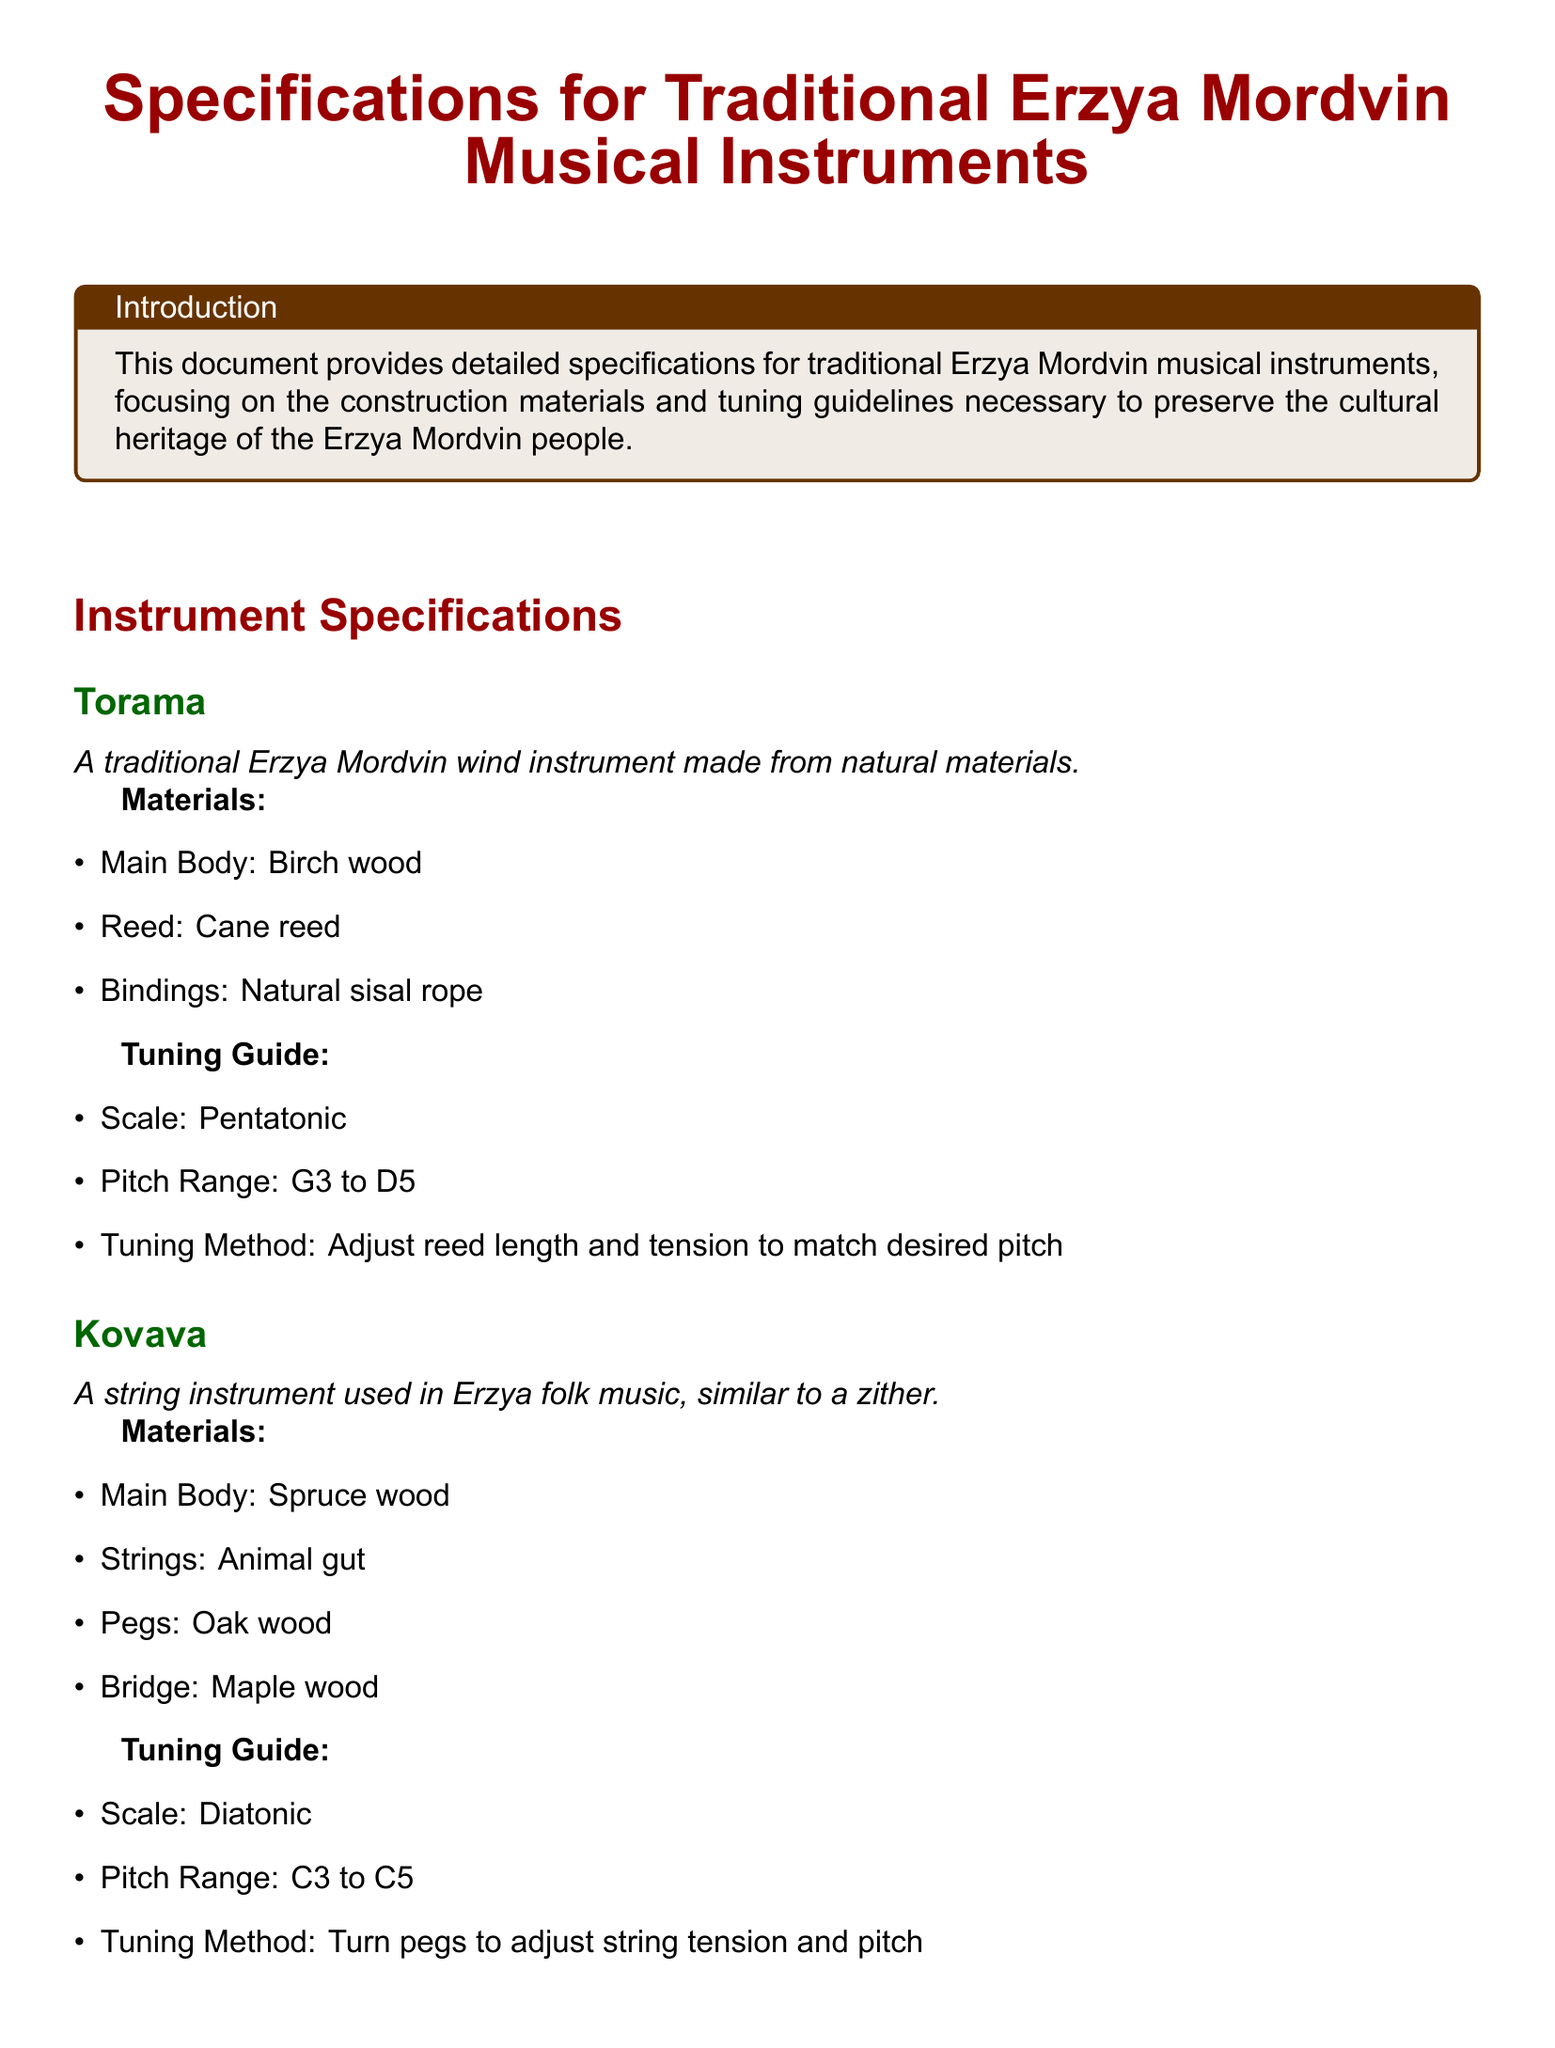What is the main body material of Torama? The main body of the Torama is made from birch wood.
Answer: Birch wood What is the pitch range of the Kovava? The pitch range of the Kovava is specified as C3 to C5.
Answer: C3 to C5 What type of instrument is Shuvyr? The Shuvyr is described as a percussion instrument.
Answer: Percussion instrument What materials are used for the bindings of Torama? The bindings of the Torama are made from natural sisal rope.
Answer: Natural sisal rope What tuning method is used for the Shuvyr? The tuning method for the Shuvyr involves tightening or loosening leather straps.
Answer: Tighten or loosen leather straps What scale does the Torama utilize? The Torama utilizes a pentatonic scale for tuning.
Answer: Pentatonic How is the tuning adjusted for the Kovava? The tuning for the Kovava is adjusted by turning pegs to change string tension and pitch.
Answer: Turn pegs to adjust string tension What type of skin is used for the membrane of Shuvyr? The membrane of the Shuvyr is made from animal skin.
Answer: Animal skin What is the main body material of Kovava? The main body of the Kovava is made from spruce wood.
Answer: Spruce wood 